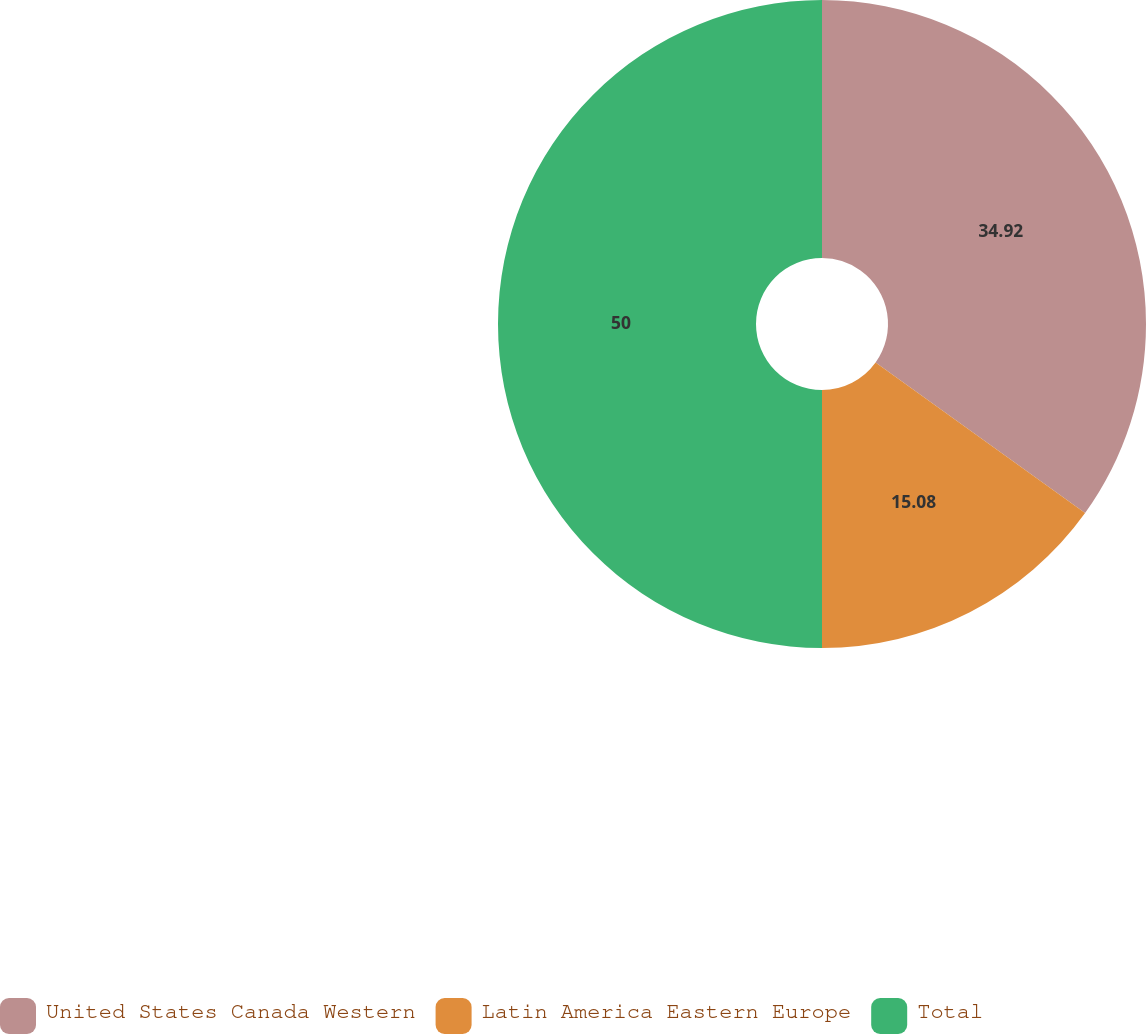Convert chart. <chart><loc_0><loc_0><loc_500><loc_500><pie_chart><fcel>United States Canada Western<fcel>Latin America Eastern Europe<fcel>Total<nl><fcel>34.92%<fcel>15.08%<fcel>50.0%<nl></chart> 